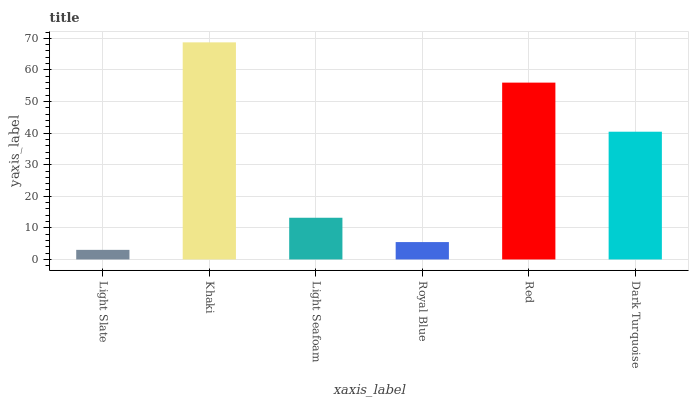Is Light Slate the minimum?
Answer yes or no. Yes. Is Khaki the maximum?
Answer yes or no. Yes. Is Light Seafoam the minimum?
Answer yes or no. No. Is Light Seafoam the maximum?
Answer yes or no. No. Is Khaki greater than Light Seafoam?
Answer yes or no. Yes. Is Light Seafoam less than Khaki?
Answer yes or no. Yes. Is Light Seafoam greater than Khaki?
Answer yes or no. No. Is Khaki less than Light Seafoam?
Answer yes or no. No. Is Dark Turquoise the high median?
Answer yes or no. Yes. Is Light Seafoam the low median?
Answer yes or no. Yes. Is Red the high median?
Answer yes or no. No. Is Dark Turquoise the low median?
Answer yes or no. No. 